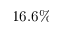<formula> <loc_0><loc_0><loc_500><loc_500>1 6 . 6 \%</formula> 